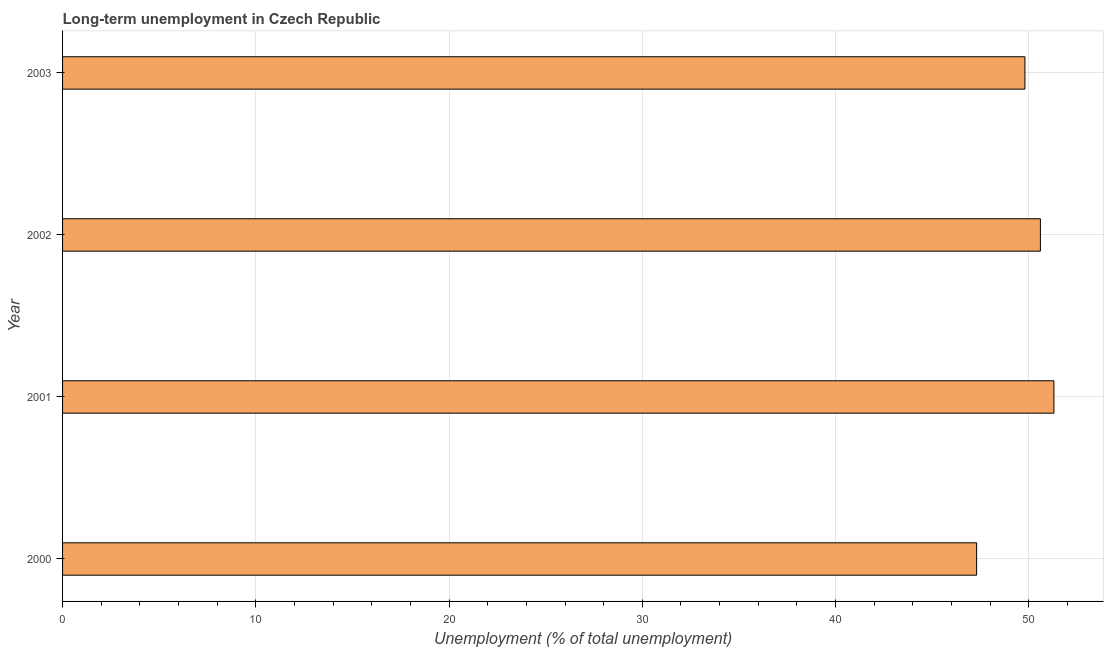Does the graph contain any zero values?
Your answer should be very brief. No. What is the title of the graph?
Ensure brevity in your answer.  Long-term unemployment in Czech Republic. What is the label or title of the X-axis?
Provide a short and direct response. Unemployment (% of total unemployment). What is the long-term unemployment in 2002?
Offer a terse response. 50.6. Across all years, what is the maximum long-term unemployment?
Provide a short and direct response. 51.3. Across all years, what is the minimum long-term unemployment?
Make the answer very short. 47.3. In which year was the long-term unemployment minimum?
Your answer should be compact. 2000. What is the sum of the long-term unemployment?
Your response must be concise. 199. What is the average long-term unemployment per year?
Provide a short and direct response. 49.75. What is the median long-term unemployment?
Make the answer very short. 50.2. In how many years, is the long-term unemployment greater than 46 %?
Ensure brevity in your answer.  4. What is the ratio of the long-term unemployment in 2000 to that in 2001?
Give a very brief answer. 0.92. Is the long-term unemployment in 2001 less than that in 2002?
Give a very brief answer. No. What is the difference between the highest and the lowest long-term unemployment?
Your response must be concise. 4. How many bars are there?
Provide a succinct answer. 4. How many years are there in the graph?
Ensure brevity in your answer.  4. What is the difference between two consecutive major ticks on the X-axis?
Your answer should be very brief. 10. Are the values on the major ticks of X-axis written in scientific E-notation?
Your response must be concise. No. What is the Unemployment (% of total unemployment) of 2000?
Offer a terse response. 47.3. What is the Unemployment (% of total unemployment) in 2001?
Give a very brief answer. 51.3. What is the Unemployment (% of total unemployment) in 2002?
Your response must be concise. 50.6. What is the Unemployment (% of total unemployment) of 2003?
Provide a succinct answer. 49.8. What is the difference between the Unemployment (% of total unemployment) in 2000 and 2001?
Ensure brevity in your answer.  -4. What is the difference between the Unemployment (% of total unemployment) in 2000 and 2002?
Provide a succinct answer. -3.3. What is the difference between the Unemployment (% of total unemployment) in 2000 and 2003?
Offer a terse response. -2.5. What is the ratio of the Unemployment (% of total unemployment) in 2000 to that in 2001?
Provide a short and direct response. 0.92. What is the ratio of the Unemployment (% of total unemployment) in 2000 to that in 2002?
Make the answer very short. 0.94. What is the ratio of the Unemployment (% of total unemployment) in 2000 to that in 2003?
Offer a terse response. 0.95. What is the ratio of the Unemployment (% of total unemployment) in 2001 to that in 2002?
Your answer should be very brief. 1.01. 